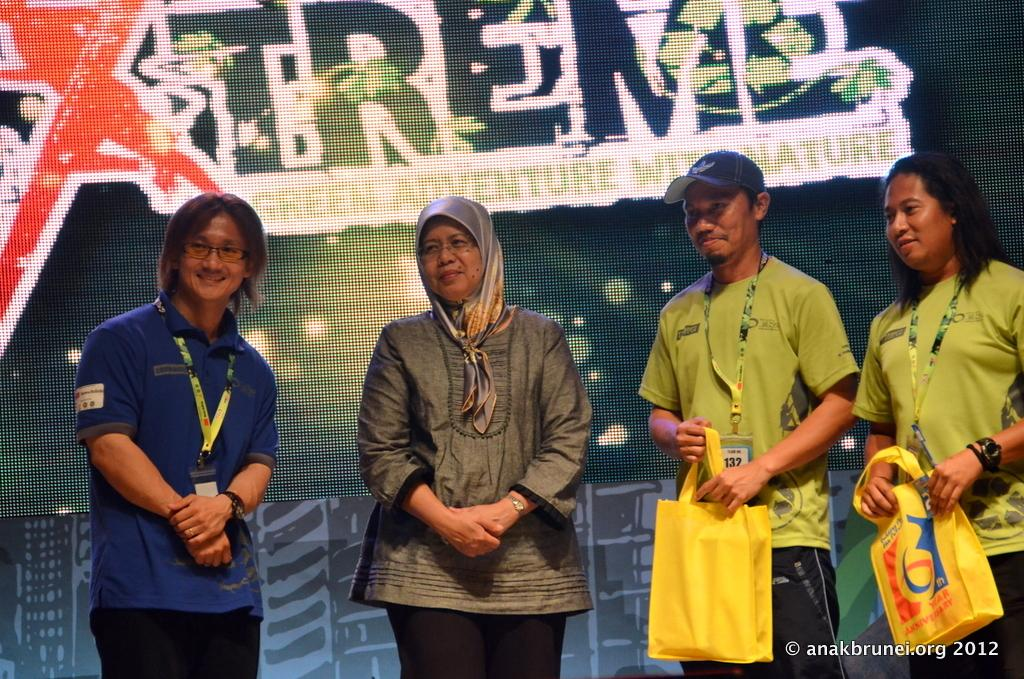How many people are in the foreground of the image? There are four persons in the foreground of the image. What can be seen in the background of the image? There is a screen in the background of the image. Where is the text located in the image? The text is at the right side bottom of the image. What type of wine is being served in the scene depicted in the image? There is no scene or wine present in the image; it features four persons in the foreground and a screen in the background. 